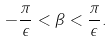Convert formula to latex. <formula><loc_0><loc_0><loc_500><loc_500>- \frac { \pi } { \epsilon } < \beta < \frac { \pi } { \epsilon } .</formula> 